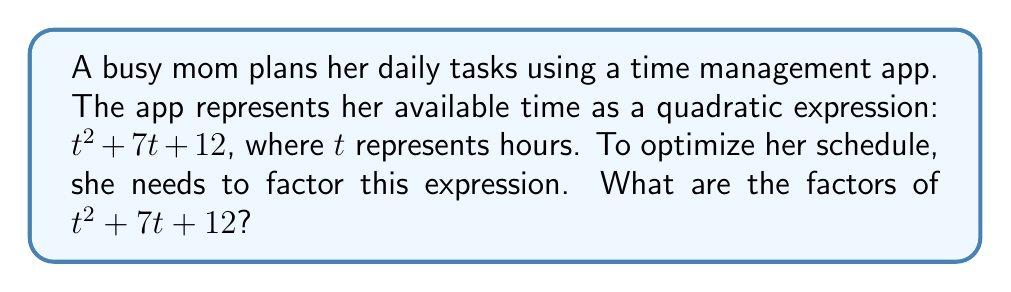Give your solution to this math problem. To factor the quadratic expression $t^2 + 7t + 12$, we'll follow these steps:

1) First, identify the coefficients:
   $a = 1$, $b = 7$, and $c = 12$

2) We need to find two numbers that multiply to give $ac = 1 \times 12 = 12$ and add up to $b = 7$.

3) The factors of 12 are: 1, 2, 3, 4, 6, and 12.

4) By inspection, we can see that 3 and 4 multiply to give 12 and add up to 7.

5) Therefore, we can rewrite the middle term as: $7t = 3t + 4t$

6) Now, we can rewrite the expression as:
   $t^2 + 3t + 4t + 12$

7) Grouping the terms:
   $(t^2 + 3t) + (4t + 12)$

8) Factoring out the common factors from each group:
   $t(t + 3) + 4(t + 3)$

9) We can now factor out the common binomial $(t + 3)$:
   $(t + 4)(t + 3)$

This factorization represents the mom's time management in two parts, helping her to visualize and plan her day more efficiently.
Answer: $(t + 4)(t + 3)$ 